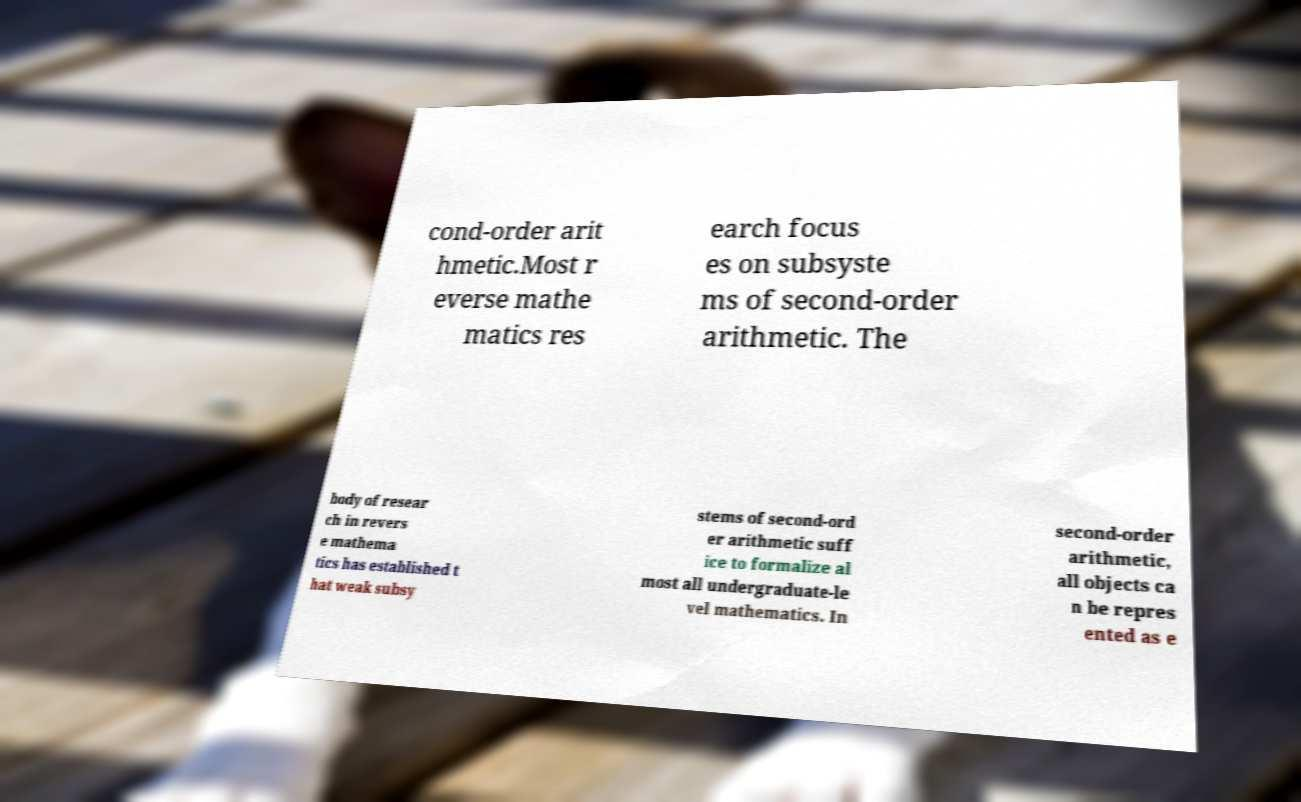Please identify and transcribe the text found in this image. cond-order arit hmetic.Most r everse mathe matics res earch focus es on subsyste ms of second-order arithmetic. The body of resear ch in revers e mathema tics has established t hat weak subsy stems of second-ord er arithmetic suff ice to formalize al most all undergraduate-le vel mathematics. In second-order arithmetic, all objects ca n be repres ented as e 